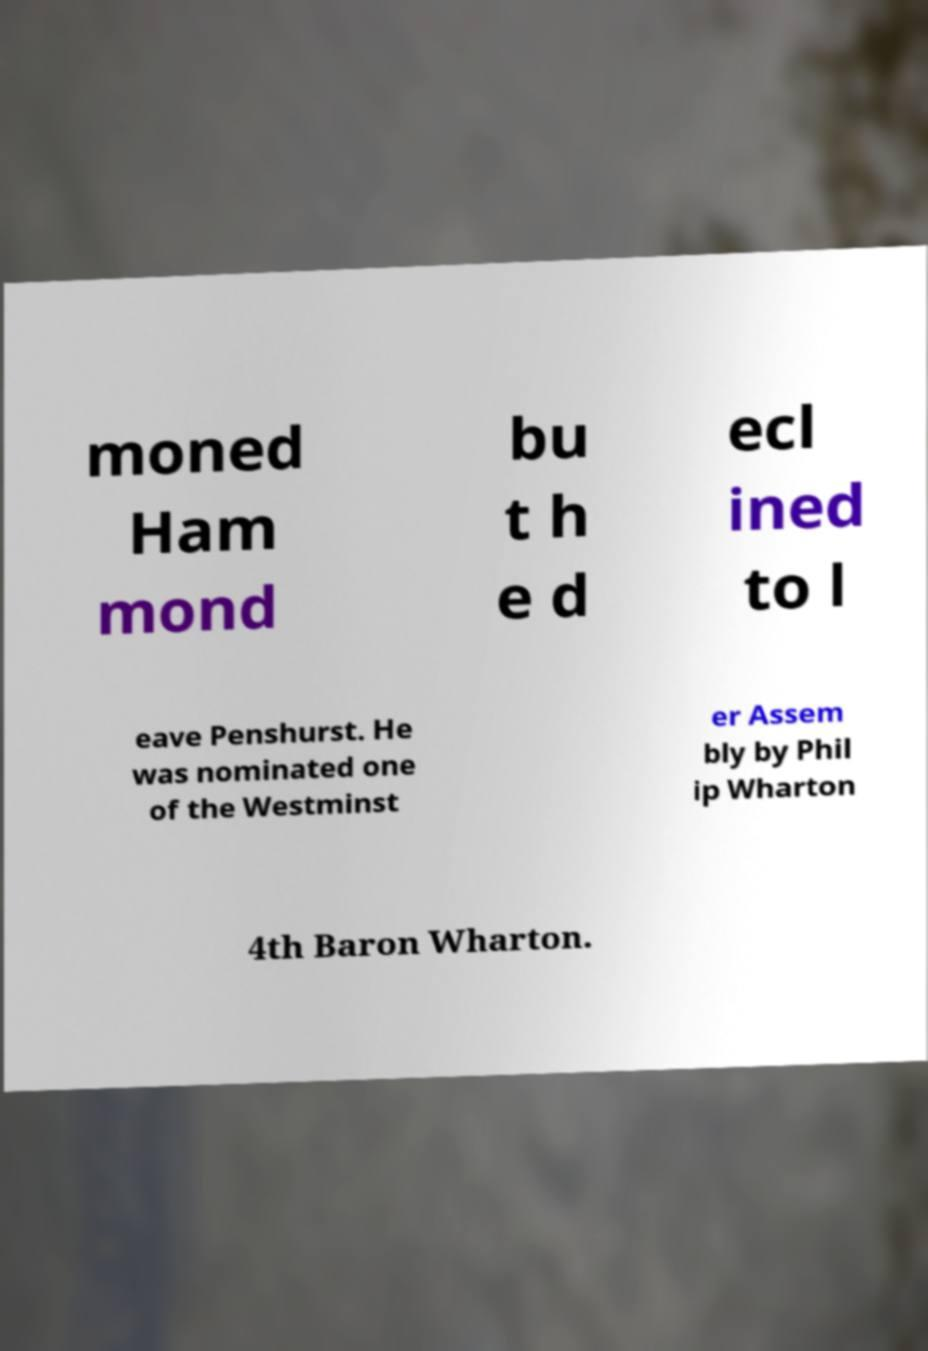Please identify and transcribe the text found in this image. moned Ham mond bu t h e d ecl ined to l eave Penshurst. He was nominated one of the Westminst er Assem bly by Phil ip Wharton 4th Baron Wharton. 